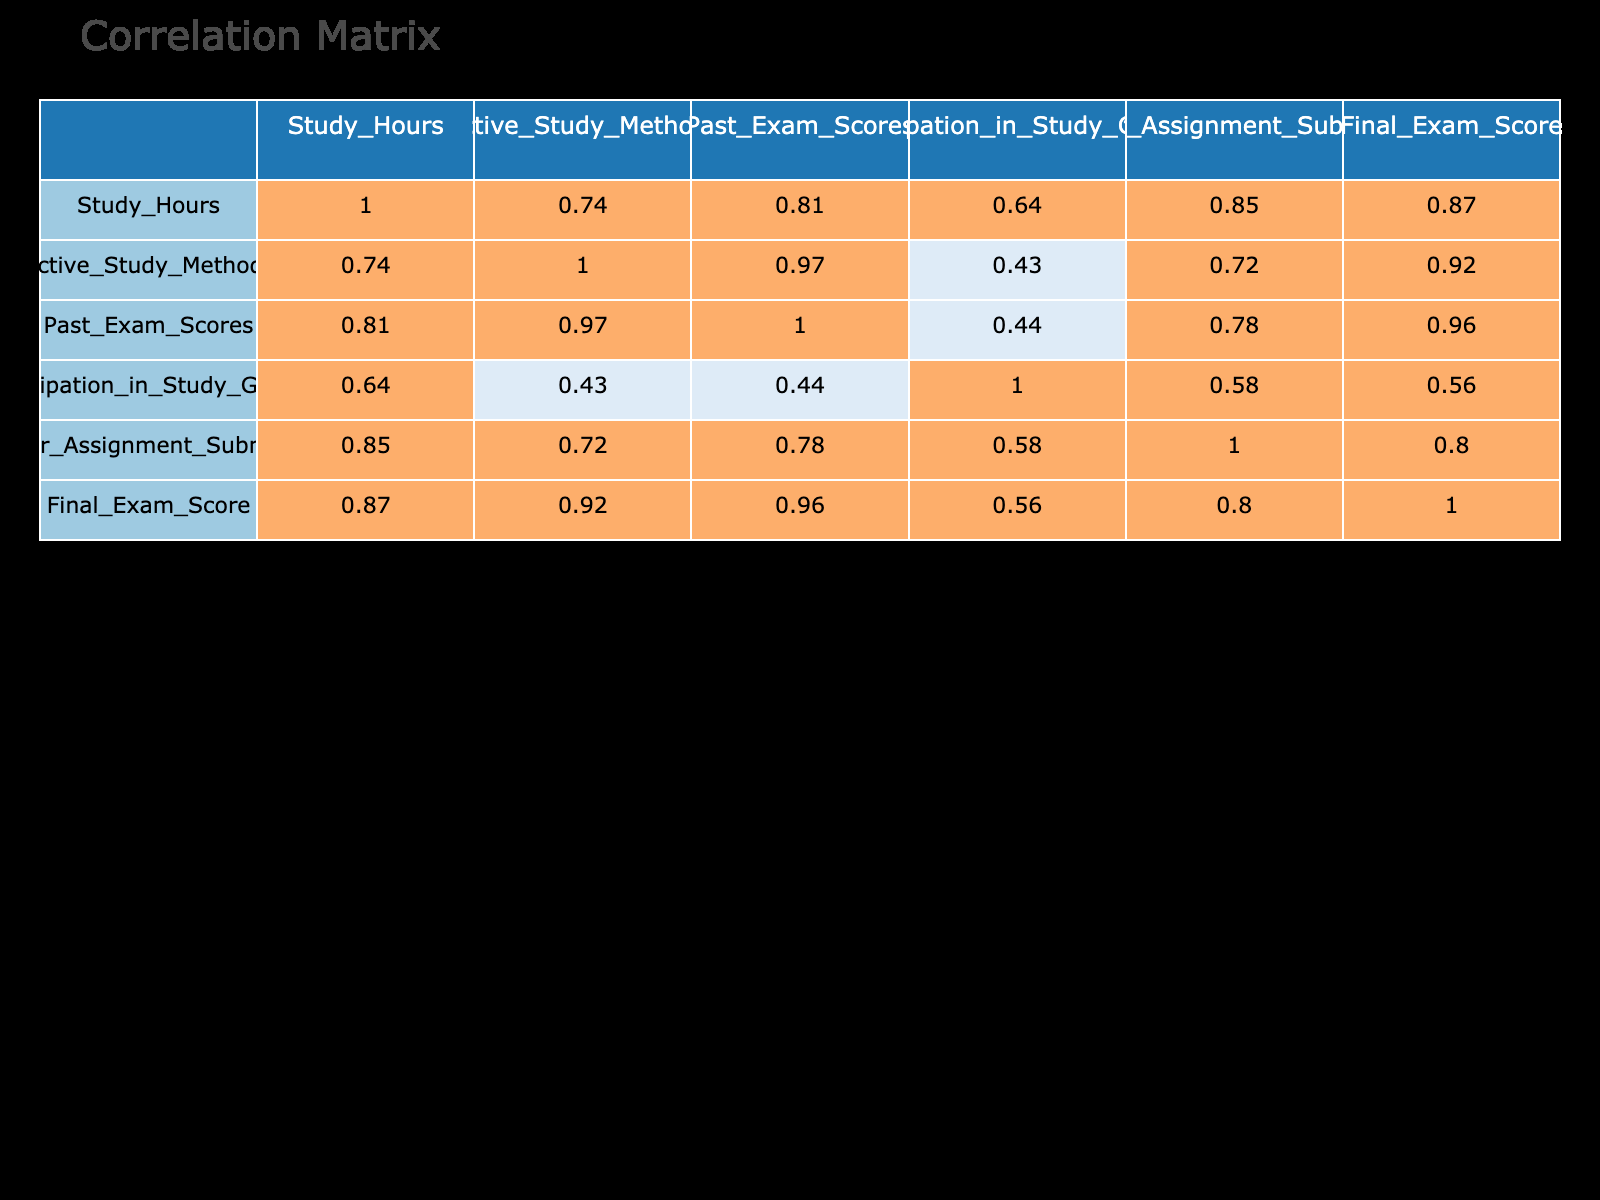What is the correlation between study hours and final exam score? The correlation coefficient between study hours and final exam score can be found in the correlation table under the respective columns. It shows a positive correlation suggesting that as study hours increase, final exam scores tend to increase as well. The exact coefficient is 0.91.
Answer: 0.91 What is the average final exam score of students who participated in study groups? To find the average final exam score for students who participated in study groups (value of ‘1’ in Participation_in_Study_Groups), we take the scores from those rows: 85, 75, 84, 83, 95. The sum is 422, and there are 5 students. Thus, the average is 422/5 = 84.4.
Answer: 84.4 Is there a strong correlation between regular assignment submission and final exam score? Looking at the correlation coefficient in the table, we see the value for regular assignment submission and final exam score is 0.65. Since this value is above 0.5, we can conclude that there is a strong positive correlation.
Answer: Yes What is the difference in the final exam score between students who studied actively (score of 3 or more in Active_Study_Methods) and those who did not? First, we identify the students with active study methods score of 3 or more: scores are 85, 75, 90, 84, 83, 95 for total of 6 students yielding an average of (85 + 75 + 90 + 84 + 83 + 95) / 6 = 85.5. Next, the students with scores less than 3 have final exam scores of 70, 78, 65, 62 for a total of 4 students, yielding an average of (70 + 78 + 65 + 62) / 4 = 68.75. The difference is 85.5 - 68.75 = 16.75.
Answer: 16.75 Is there a correlation between past exam scores and participation in study groups? The correlation coefficient between past exam scores and participation in study groups is 0.55. Since this value is above 0.5, it indicates that there is a moderate positive correlation between these two variables.
Answer: Yes 